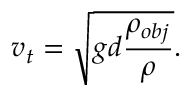<formula> <loc_0><loc_0><loc_500><loc_500>v _ { t } = { \sqrt { g d { \frac { \rho _ { o b j } } { \rho } } } } .</formula> 